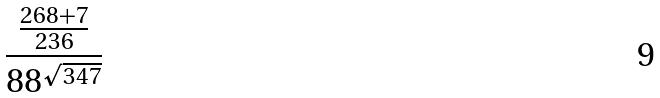Convert formula to latex. <formula><loc_0><loc_0><loc_500><loc_500>\frac { \frac { 2 6 8 + 7 } { 2 3 6 } } { 8 8 ^ { \sqrt { 3 4 7 } } }</formula> 